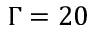Convert formula to latex. <formula><loc_0><loc_0><loc_500><loc_500>\Gamma = 2 0</formula> 